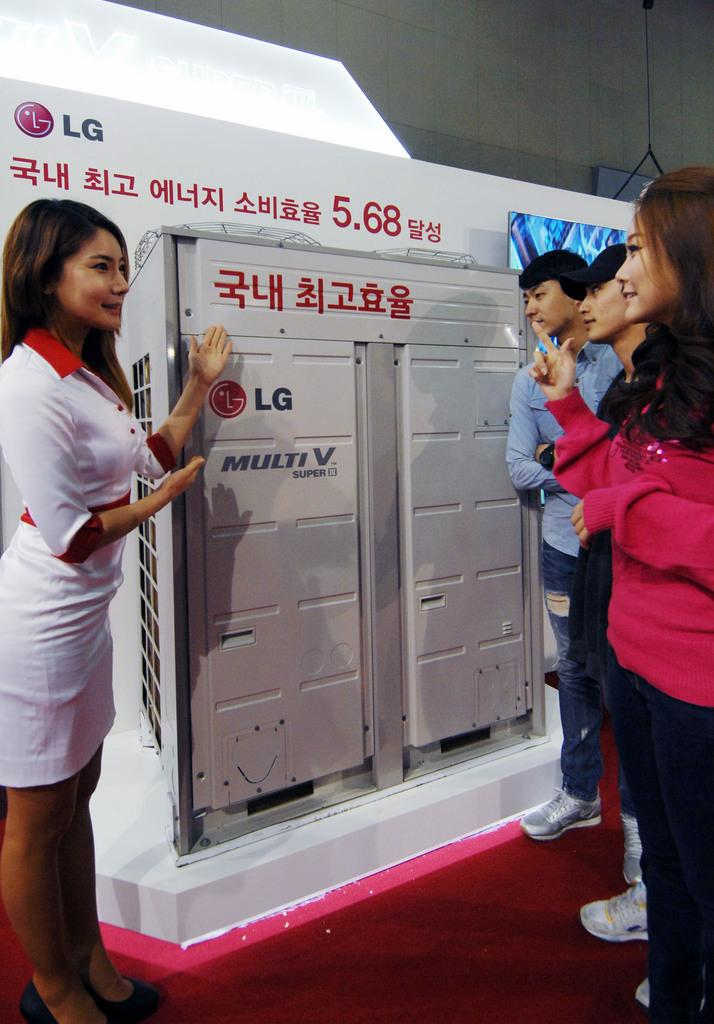Provide a one-sentence caption for the provided image. A woman is showing a LG brand device to some consumers. 